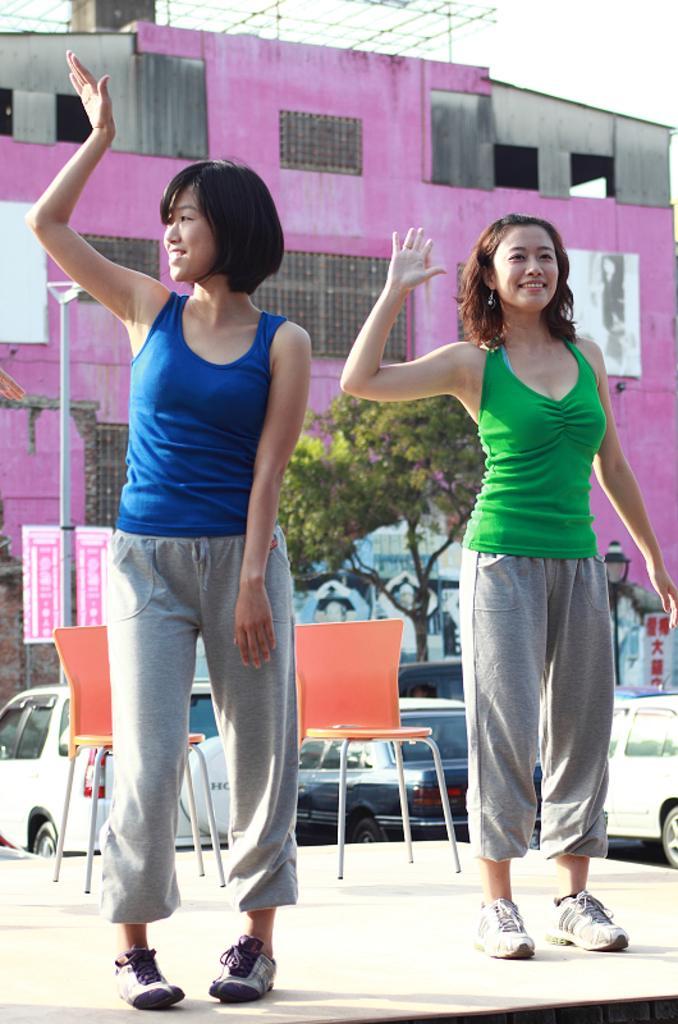Could you give a brief overview of what you see in this image? Here we can see a two woman standing on each side and looks like they are dancing. In the background we can see a house of pink color and a car. 